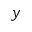Convert formula to latex. <formula><loc_0><loc_0><loc_500><loc_500>y</formula> 